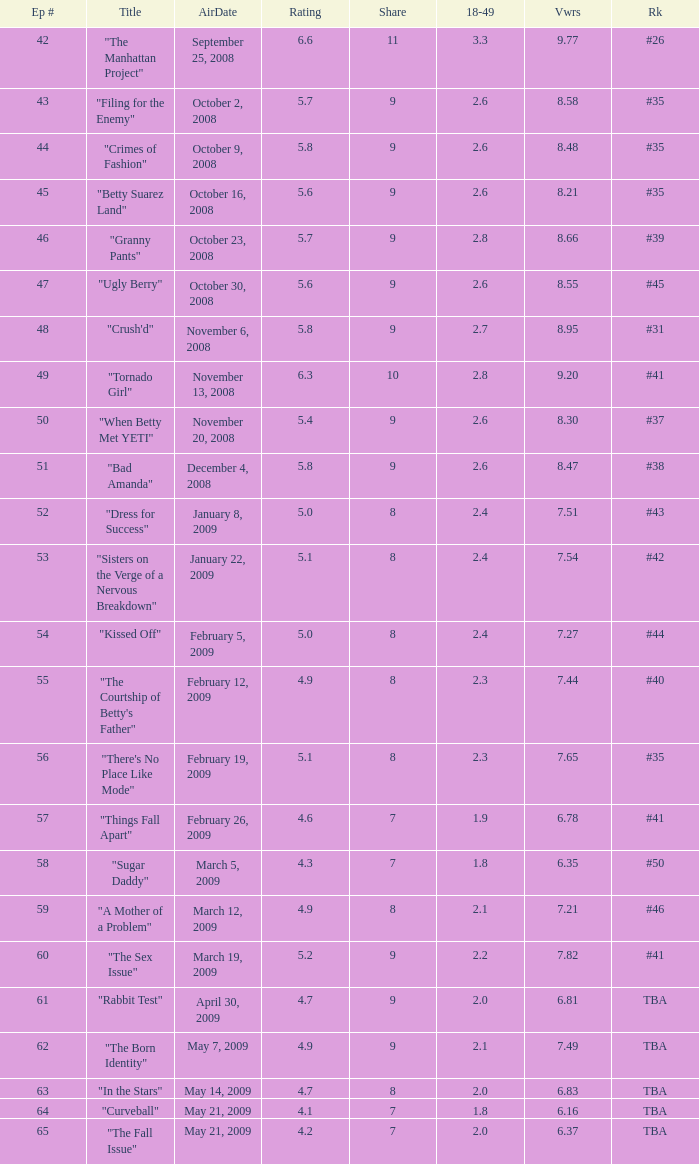What is the average Episode # with a share of 9, and #35 is rank and less than 8.21 viewers? None. 